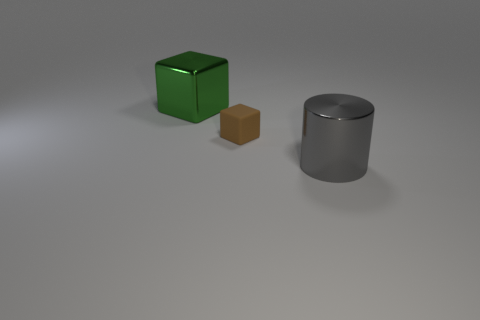How many big objects are gray shiny cylinders or cyan shiny cubes?
Your answer should be compact. 1. There is a big metal object on the left side of the large cylinder; what is its shape?
Make the answer very short. Cube. Is there a large thing of the same color as the big metal cube?
Keep it short and to the point. No. Do the block in front of the large green metal block and the metallic thing that is to the left of the brown rubber object have the same size?
Your response must be concise. No. Is the number of metallic cylinders that are left of the brown rubber cube greater than the number of green blocks on the right side of the large cylinder?
Your response must be concise. No. Is there a gray sphere made of the same material as the large green cube?
Provide a short and direct response. No. Does the small thing have the same color as the large metallic cylinder?
Your answer should be very brief. No. There is a object that is both behind the big cylinder and on the right side of the large metal block; what is it made of?
Make the answer very short. Rubber. What is the color of the cylinder?
Your answer should be compact. Gray. How many other things are the same shape as the tiny brown thing?
Offer a terse response. 1. 